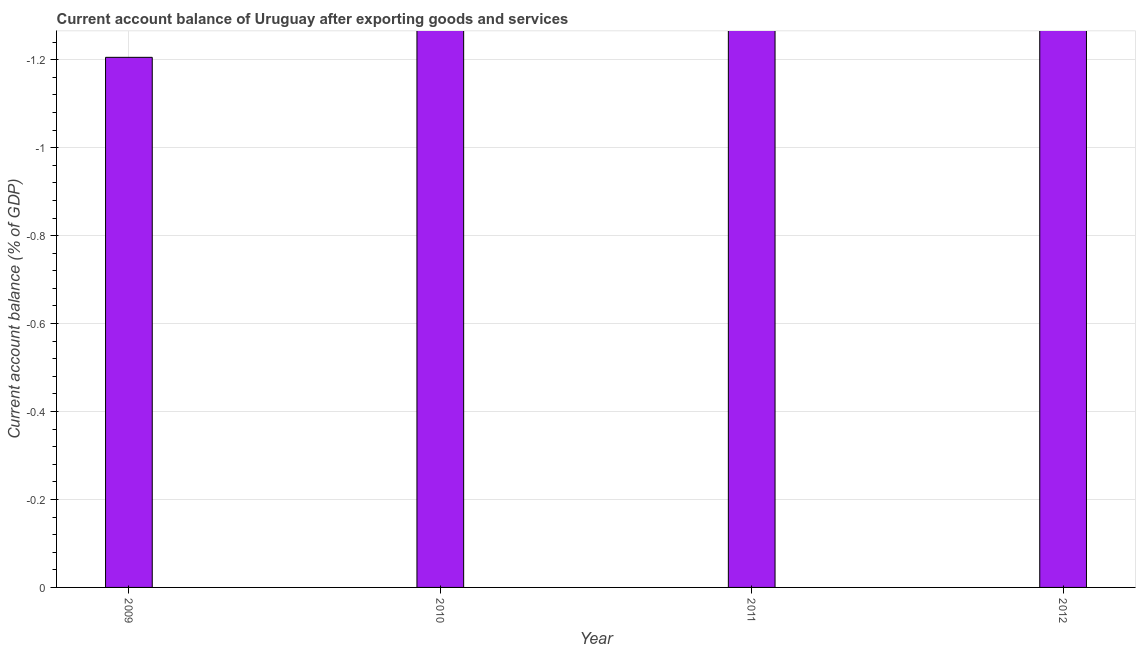Does the graph contain any zero values?
Provide a succinct answer. Yes. Does the graph contain grids?
Your answer should be compact. Yes. What is the title of the graph?
Ensure brevity in your answer.  Current account balance of Uruguay after exporting goods and services. What is the label or title of the X-axis?
Keep it short and to the point. Year. What is the label or title of the Y-axis?
Your response must be concise. Current account balance (% of GDP). What is the current account balance in 2010?
Your answer should be compact. 0. What is the sum of the current account balance?
Provide a short and direct response. 0. In how many years, is the current account balance greater than -0.44 %?
Offer a very short reply. 0. In how many years, is the current account balance greater than the average current account balance taken over all years?
Provide a short and direct response. 0. How many bars are there?
Give a very brief answer. 0. Are all the bars in the graph horizontal?
Your response must be concise. No. How many years are there in the graph?
Make the answer very short. 4. What is the difference between two consecutive major ticks on the Y-axis?
Give a very brief answer. 0.2. Are the values on the major ticks of Y-axis written in scientific E-notation?
Offer a terse response. No. What is the Current account balance (% of GDP) in 2009?
Keep it short and to the point. 0. What is the Current account balance (% of GDP) of 2010?
Give a very brief answer. 0. What is the Current account balance (% of GDP) in 2011?
Offer a very short reply. 0. 